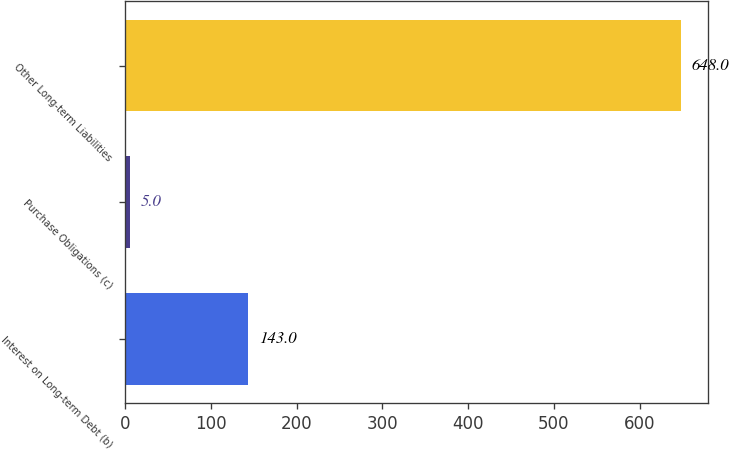<chart> <loc_0><loc_0><loc_500><loc_500><bar_chart><fcel>Interest on Long-term Debt (b)<fcel>Purchase Obligations (c)<fcel>Other Long-term Liabilities<nl><fcel>143<fcel>5<fcel>648<nl></chart> 